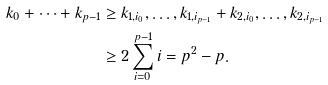<formula> <loc_0><loc_0><loc_500><loc_500>k _ { 0 } + \cdots + k _ { p - 1 } & \geq k _ { 1 , i _ { 0 } } , \dots , k _ { 1 , i _ { p - 1 } } + k _ { 2 , i _ { 0 } } , \dots , k _ { 2 , i _ { p - 1 } } \\ & \geq 2 \sum _ { i = 0 } ^ { p - 1 } i = p ^ { 2 } - p .</formula> 